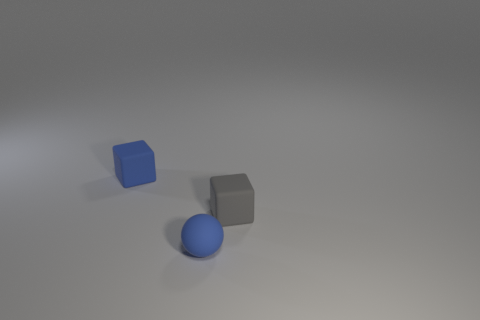Add 1 balls. How many objects exist? 4 Subtract all blocks. How many objects are left? 1 Add 3 tiny rubber cylinders. How many tiny rubber cylinders exist? 3 Subtract 0 brown blocks. How many objects are left? 3 Subtract all gray things. Subtract all small blue matte objects. How many objects are left? 0 Add 1 gray blocks. How many gray blocks are left? 2 